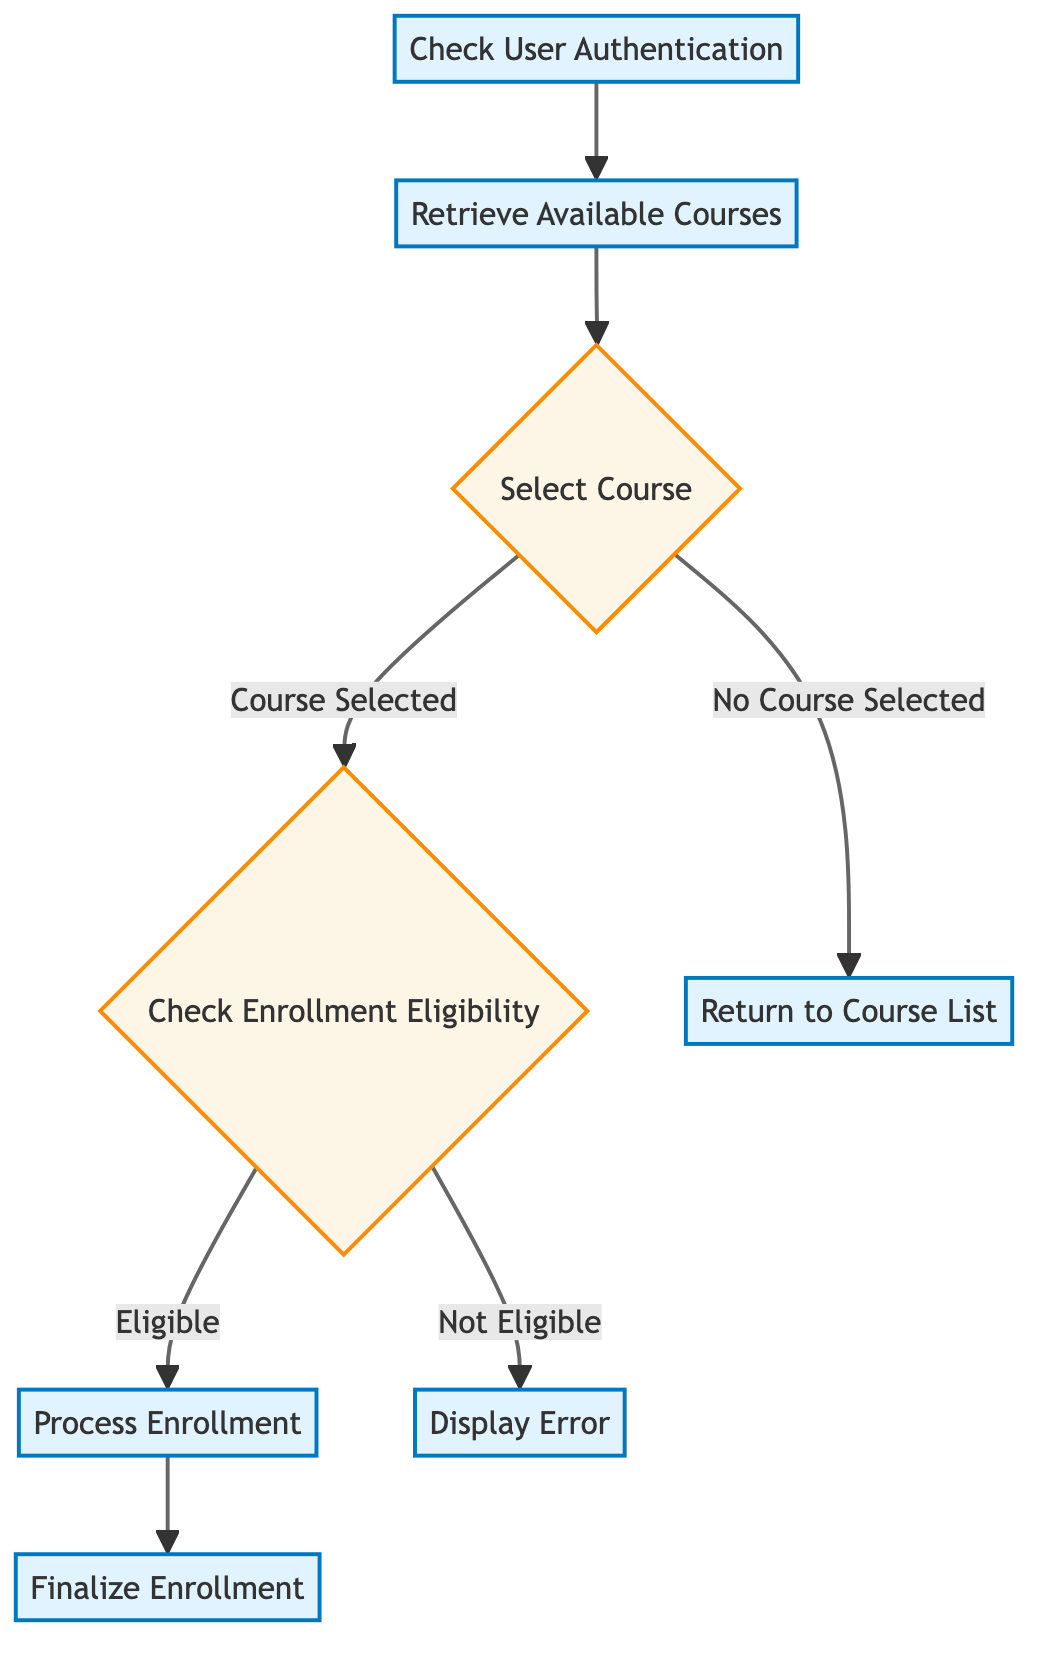What is the first step in the workflow? The first step in the workflow is "Check User Authentication," as it is the entry point of the process.
Answer: Check User Authentication How many nodes are in the diagram? By counting all the distinct steps including decisions and processes, the total number of nodes in the diagram is 8.
Answer: 8 What happens if a course is not selected? If no course is selected, the workflow leads to "Return to Course List," which indicates that the process will not continue without a selection.
Answer: Return to Course List What is the output after processing enrollment? The output after processing enrollment is the step "Finalize Enrollment," which indicates that the enrollment process is completed.
Answer: Finalize Enrollment What verification is required in the second step? In the second step, available courses are retrieved, which includes verifying the user's access level for course listings.
Answer: Filter courses based on user access level What does "Check Enrollment Eligibility" lead to if eligible? If the user is determined to be eligible in the "Check Enrollment Eligibility" step, it leads directly to the "Process Enrollment" step for further action.
Answer: Process Enrollment Which node comes after "Check User Authentication"? The node that comes after "Check User Authentication" is "Retrieve Available Courses," indicating the next action in the flow.
Answer: Retrieve Available Courses What is displayed if the user is not eligible? If the user is not eligible, the system generates an error as indicated by the step "Display Error" in the workflow.
Answer: Display Error What is the final step in the course enrollment workflow? The final step in the course enrollment workflow is "Finalize Enrollment," which completes the user's enrollment process.
Answer: Finalize Enrollment 